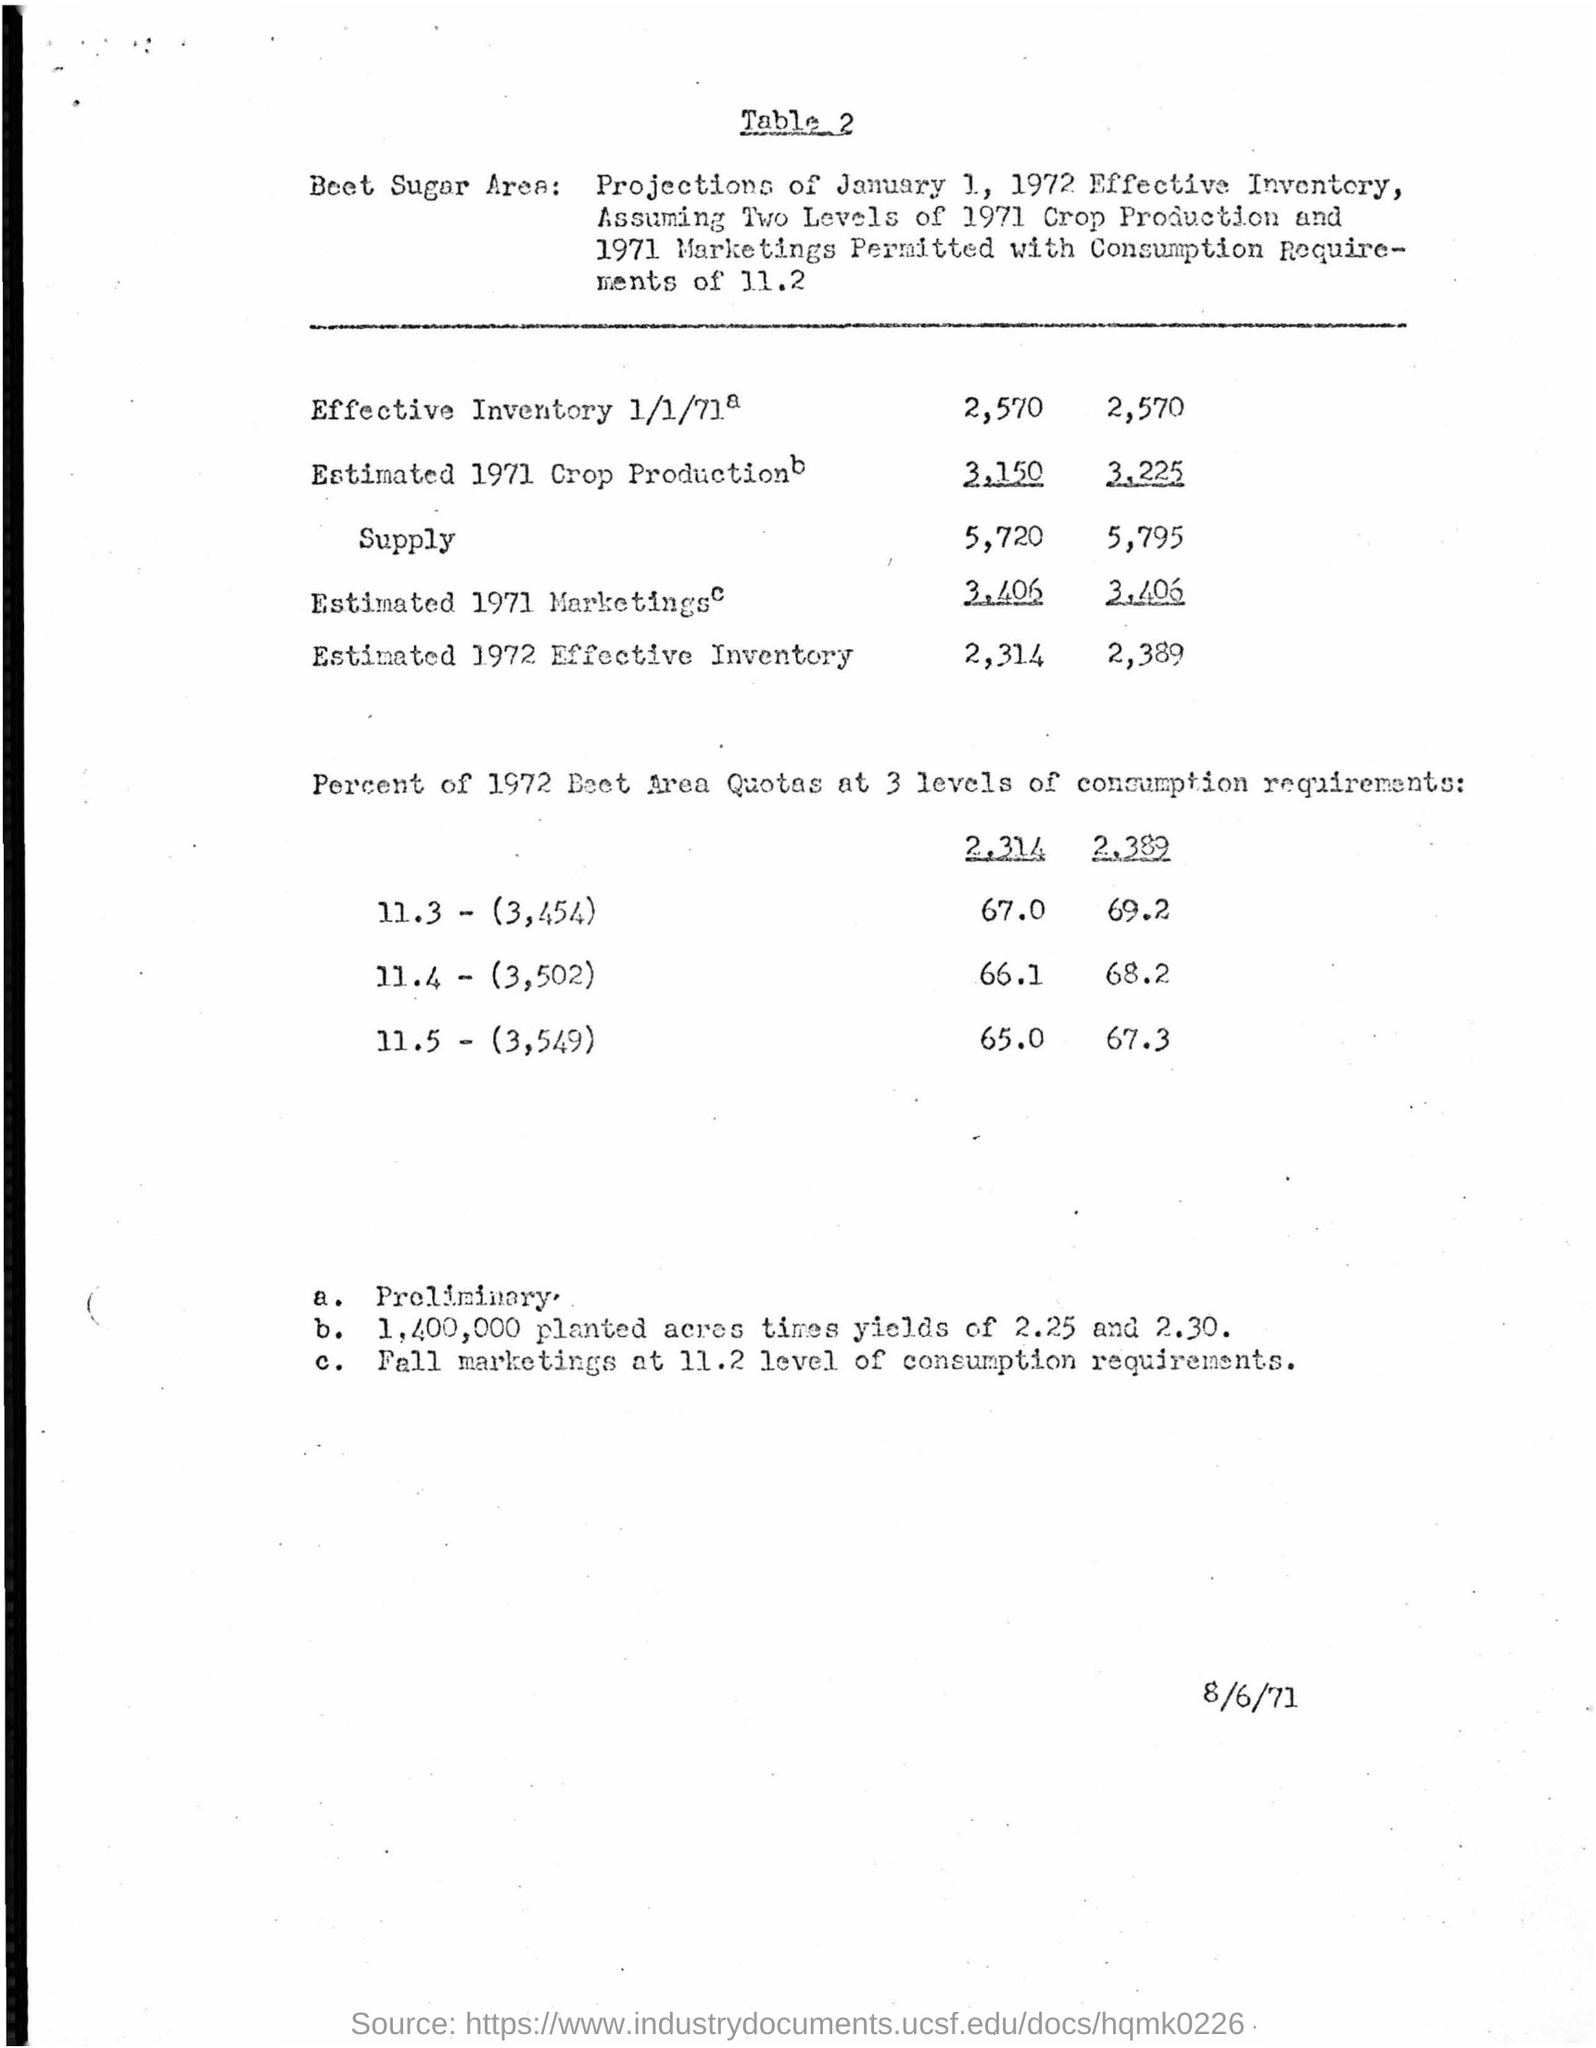Mention a couple of crucial points in this snapshot. The date mentioned at the bottom of the document is August 6, 1971. The main heading of the document is 'Table 2'. 